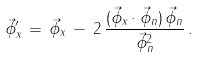<formula> <loc_0><loc_0><loc_500><loc_500>\vec { \phi } _ { x } ^ { \prime } \, = \, \vec { \phi } _ { x } \, - \, 2 \, \frac { ( \vec { \phi } _ { x } \cdot \vec { \phi } _ { n } ) \, \vec { \phi } _ { n } } { \vec { \phi } _ { n } ^ { 2 } } \, .</formula> 